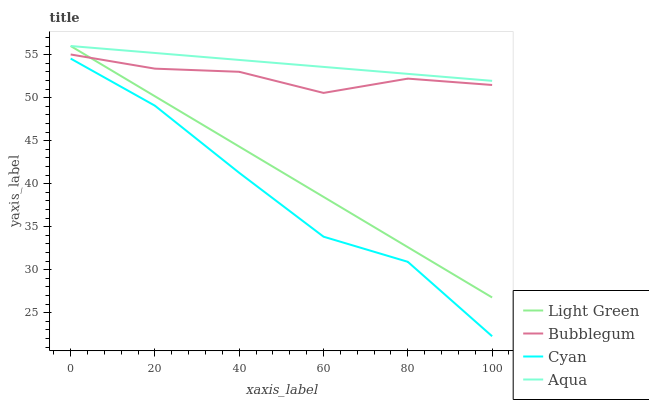Does Cyan have the minimum area under the curve?
Answer yes or no. Yes. Does Aqua have the maximum area under the curve?
Answer yes or no. Yes. Does Bubblegum have the minimum area under the curve?
Answer yes or no. No. Does Bubblegum have the maximum area under the curve?
Answer yes or no. No. Is Aqua the smoothest?
Answer yes or no. Yes. Is Cyan the roughest?
Answer yes or no. Yes. Is Bubblegum the smoothest?
Answer yes or no. No. Is Bubblegum the roughest?
Answer yes or no. No. Does Cyan have the lowest value?
Answer yes or no. Yes. Does Bubblegum have the lowest value?
Answer yes or no. No. Does Light Green have the highest value?
Answer yes or no. Yes. Does Bubblegum have the highest value?
Answer yes or no. No. Is Cyan less than Bubblegum?
Answer yes or no. Yes. Is Light Green greater than Cyan?
Answer yes or no. Yes. Does Light Green intersect Bubblegum?
Answer yes or no. Yes. Is Light Green less than Bubblegum?
Answer yes or no. No. Is Light Green greater than Bubblegum?
Answer yes or no. No. Does Cyan intersect Bubblegum?
Answer yes or no. No. 